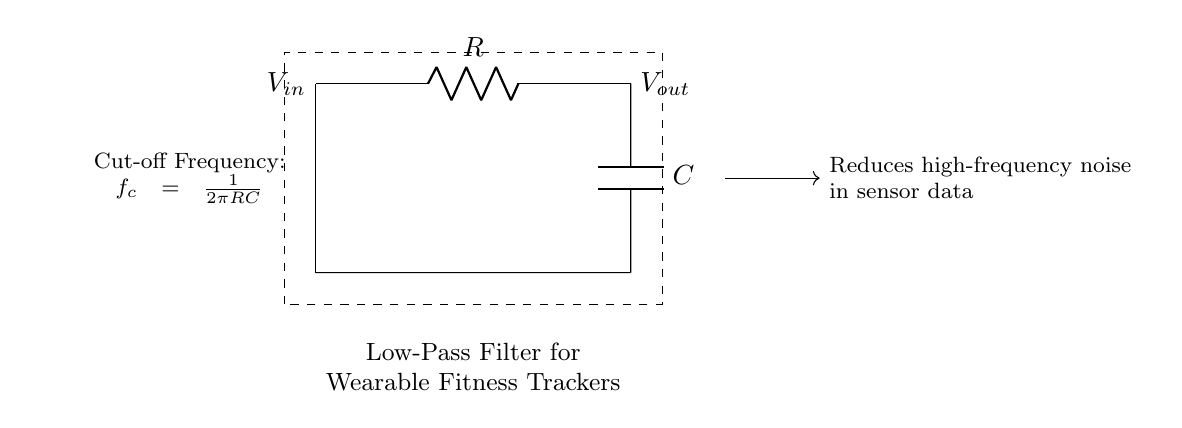What components are present in the circuit? The circuit contains a resistor denoted as R and a capacitor denoted as C. These components are typical for a low-pass filter design and are clearly labeled in the diagram.
Answer: Resistor and Capacitor What is the input voltage labeled in this circuit? The input voltage is labeled as V_in, which is indicated on the left side of the circuit diagram. This shows where the input signal is connected to the low-pass filter.
Answer: V_in What is the output voltage labeled in this circuit? The output voltage is labeled as V_out, which is indicated on the right side of the circuit. This signifies the point where the filtered output signal can be measured.
Answer: V_out What is the purpose of this low-pass filter? The purpose is to reduce high-frequency noise in sensor data. This is noted in the explanatory text beside the circuit, highlighting its application in wearable fitness trackers to enhance signal quality.
Answer: Reduce high-frequency noise What happens to the cutoff frequency as resistance increases? The cutoff frequency is defined by the equation \(f_c = \frac{1}{2\pi RC}\). As resistance (R) increases, \(f_c\) decreases, indicating that the filter will allow lower frequencies to pass while attenuating higher frequencies. This relationship is derived from understanding the effect of R in the formula.
Answer: Decreases At what frequency does this filter begin to attenuate signals? The frequency at which the filter begins to attenuate signals is defined as the cutoff frequency (f_c), which is calculated using the formula \(f_c = \frac{1}{2\pi RC}\). The variations in R and C will affect this frequency.
Answer: Cutoff frequency What kind of signals would this filter primarily pass? This low-pass filter is designed to pass low-frequency signals. Given its design and the physics of filtering, it allows those signals below the cutoff frequency to pass through while attenuating higher frequencies.
Answer: Low-frequency signals 